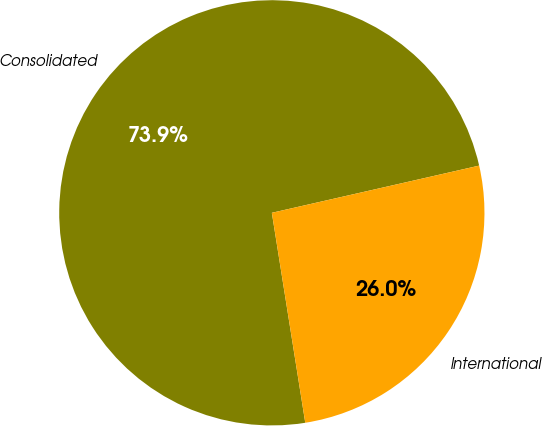<chart> <loc_0><loc_0><loc_500><loc_500><pie_chart><fcel>Consolidated<fcel>International<nl><fcel>73.95%<fcel>26.05%<nl></chart> 